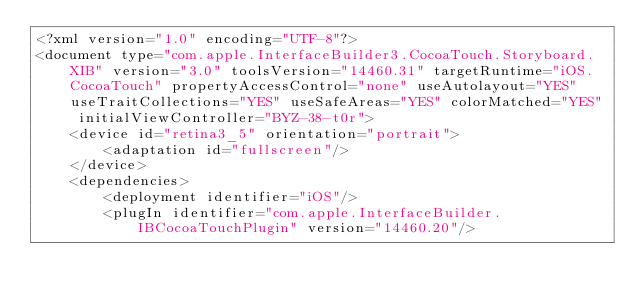Convert code to text. <code><loc_0><loc_0><loc_500><loc_500><_XML_><?xml version="1.0" encoding="UTF-8"?>
<document type="com.apple.InterfaceBuilder3.CocoaTouch.Storyboard.XIB" version="3.0" toolsVersion="14460.31" targetRuntime="iOS.CocoaTouch" propertyAccessControl="none" useAutolayout="YES" useTraitCollections="YES" useSafeAreas="YES" colorMatched="YES" initialViewController="BYZ-38-t0r">
    <device id="retina3_5" orientation="portrait">
        <adaptation id="fullscreen"/>
    </device>
    <dependencies>
        <deployment identifier="iOS"/>
        <plugIn identifier="com.apple.InterfaceBuilder.IBCocoaTouchPlugin" version="14460.20"/></code> 